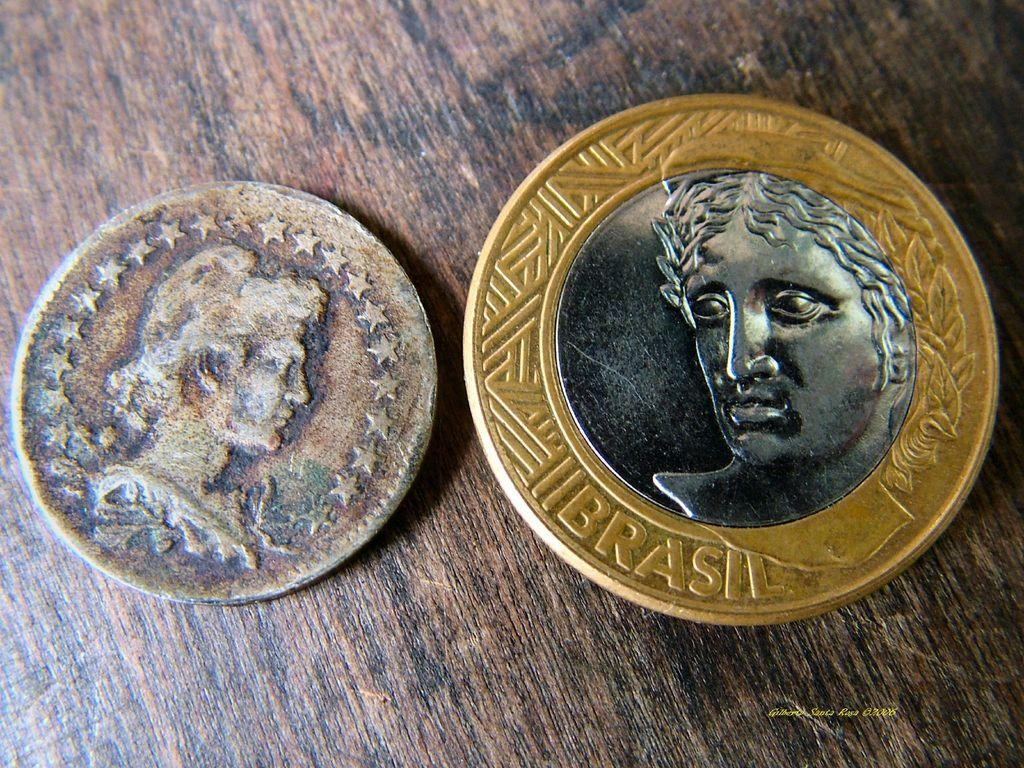<image>
Create a compact narrative representing the image presented. two coins laying on table that look like they are from brasil. 